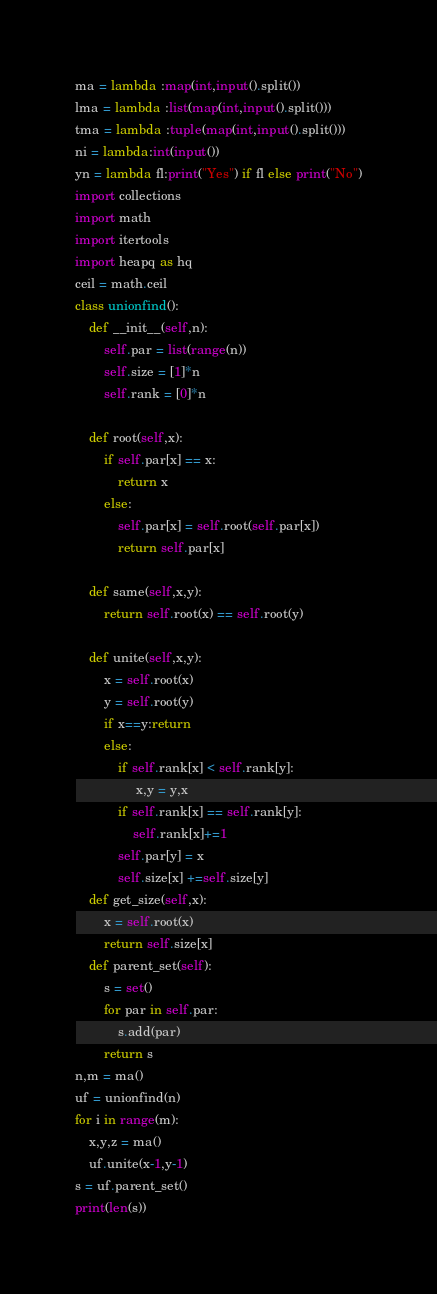Convert code to text. <code><loc_0><loc_0><loc_500><loc_500><_Python_>ma = lambda :map(int,input().split())
lma = lambda :list(map(int,input().split()))
tma = lambda :tuple(map(int,input().split()))
ni = lambda:int(input())
yn = lambda fl:print("Yes") if fl else print("No")
import collections
import math
import itertools
import heapq as hq
ceil = math.ceil
class unionfind():
    def __init__(self,n):
        self.par = list(range(n))
        self.size = [1]*n
        self.rank = [0]*n

    def root(self,x):
        if self.par[x] == x:
            return x
        else:
            self.par[x] = self.root(self.par[x])
            return self.par[x]

    def same(self,x,y):
        return self.root(x) == self.root(y)

    def unite(self,x,y):
        x = self.root(x)
        y = self.root(y)
        if x==y:return
        else:
            if self.rank[x] < self.rank[y]:
                 x,y = y,x
            if self.rank[x] == self.rank[y]:
                self.rank[x]+=1
            self.par[y] = x
            self.size[x] +=self.size[y]
    def get_size(self,x):
        x = self.root(x)
        return self.size[x]
    def parent_set(self):
        s = set()
        for par in self.par:
            s.add(par)
        return s
n,m = ma()
uf = unionfind(n)
for i in range(m):
    x,y,z = ma()
    uf.unite(x-1,y-1)
s = uf.parent_set()
print(len(s))
</code> 